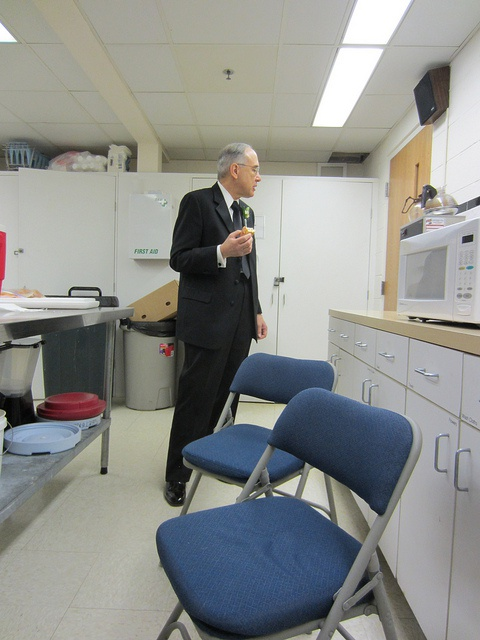Describe the objects in this image and their specific colors. I can see chair in darkgray, blue, gray, navy, and black tones, people in darkgray, black, and gray tones, chair in darkgray, blue, gray, and black tones, microwave in darkgray and lightgray tones, and tie in darkgray, black, and gray tones in this image. 